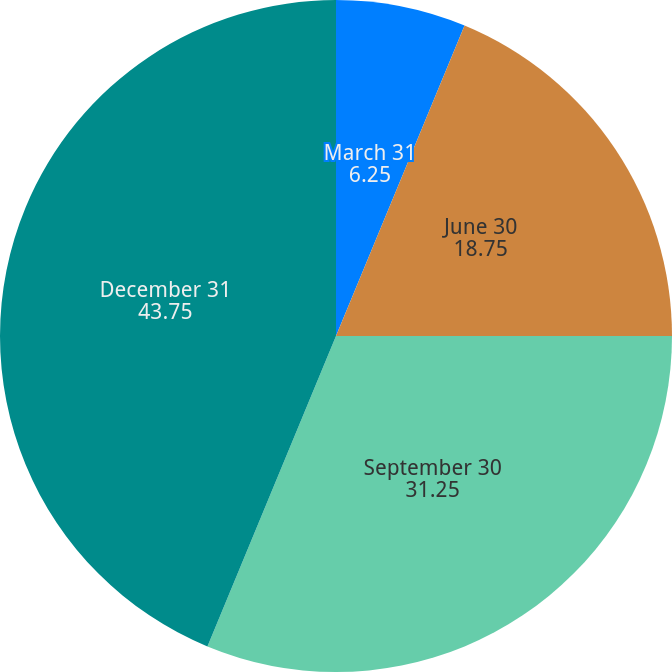Convert chart. <chart><loc_0><loc_0><loc_500><loc_500><pie_chart><fcel>March 31<fcel>June 30<fcel>September 30<fcel>December 31<nl><fcel>6.25%<fcel>18.75%<fcel>31.25%<fcel>43.75%<nl></chart> 